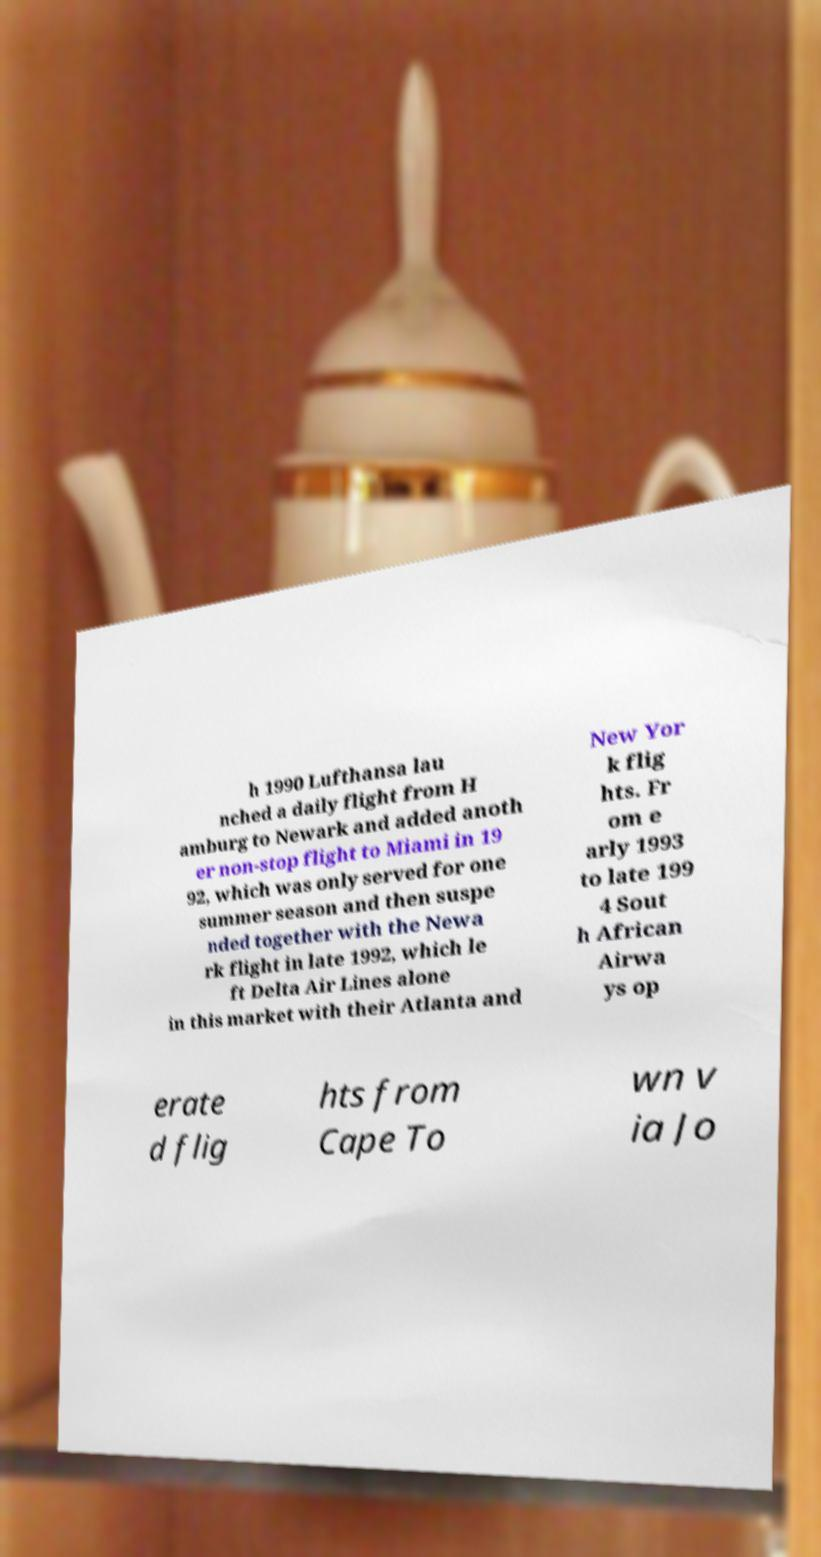What messages or text are displayed in this image? I need them in a readable, typed format. h 1990 Lufthansa lau nched a daily flight from H amburg to Newark and added anoth er non-stop flight to Miami in 19 92, which was only served for one summer season and then suspe nded together with the Newa rk flight in late 1992, which le ft Delta Air Lines alone in this market with their Atlanta and New Yor k flig hts. Fr om e arly 1993 to late 199 4 Sout h African Airwa ys op erate d flig hts from Cape To wn v ia Jo 